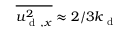<formula> <loc_0><loc_0><loc_500><loc_500>\overline { { { u _ { d , x } ^ { 2 } } } } \approx 2 / 3 k _ { d }</formula> 